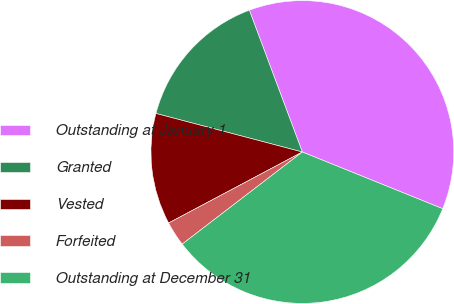Convert chart. <chart><loc_0><loc_0><loc_500><loc_500><pie_chart><fcel>Outstanding at January 1<fcel>Granted<fcel>Vested<fcel>Forfeited<fcel>Outstanding at December 31<nl><fcel>36.81%<fcel>15.21%<fcel>11.87%<fcel>2.64%<fcel>33.48%<nl></chart> 